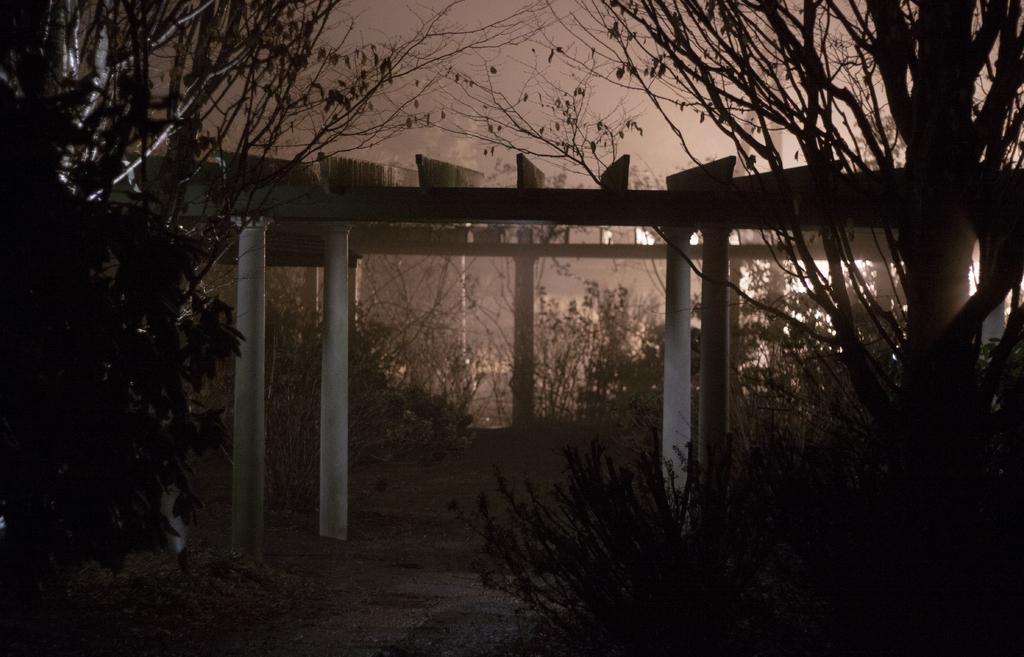What type of structure is present in the image? There is a shed in the image. What other natural elements can be seen in the image? There are trees in the image. Are there any man-made structures or objects besides the shed? Yes, there are poles in the image. What can be seen in the background of the image? The sky is visible in the background of the image. What advertisement can be seen on the side of the shed in the image? There is no advertisement present on the shed in the image. Can you describe the stranger standing near the shed in the image? There is no stranger present near the shed in the image. 